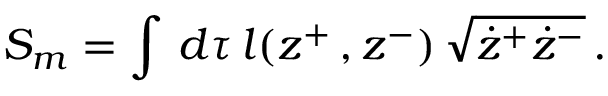<formula> <loc_0><loc_0><loc_500><loc_500>S _ { m } = \int \, d \tau \, l ( z ^ { + } \, , z ^ { - } ) \, \sqrt { \dot { z } ^ { + } \dot { z } ^ { - } } \, .</formula> 